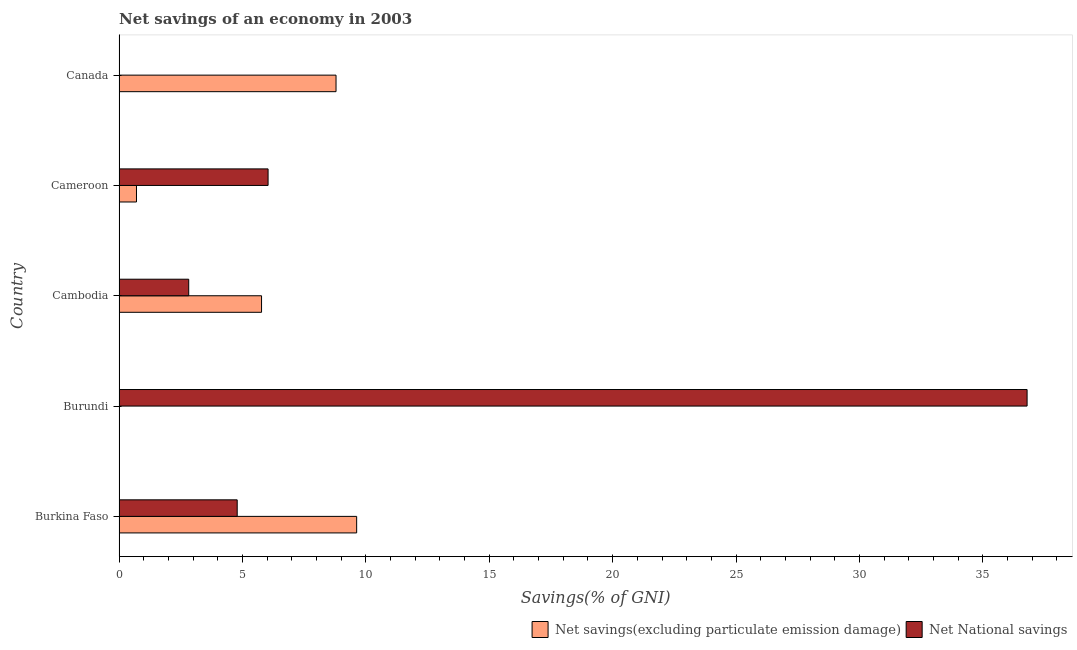Are the number of bars per tick equal to the number of legend labels?
Give a very brief answer. No. Are the number of bars on each tick of the Y-axis equal?
Keep it short and to the point. No. What is the label of the 2nd group of bars from the top?
Ensure brevity in your answer.  Cameroon. What is the net national savings in Burundi?
Make the answer very short. 36.79. Across all countries, what is the maximum net savings(excluding particulate emission damage)?
Your response must be concise. 9.63. In which country was the net savings(excluding particulate emission damage) maximum?
Your answer should be very brief. Burkina Faso. What is the total net savings(excluding particulate emission damage) in the graph?
Make the answer very short. 24.9. What is the difference between the net savings(excluding particulate emission damage) in Cambodia and that in Cameroon?
Provide a succinct answer. 5.07. What is the difference between the net national savings in Burundi and the net savings(excluding particulate emission damage) in Cambodia?
Ensure brevity in your answer.  31.02. What is the average net savings(excluding particulate emission damage) per country?
Ensure brevity in your answer.  4.98. What is the difference between the net savings(excluding particulate emission damage) and net national savings in Burkina Faso?
Provide a short and direct response. 4.84. In how many countries, is the net savings(excluding particulate emission damage) greater than 15 %?
Make the answer very short. 0. What is the ratio of the net national savings in Burundi to that in Cameroon?
Your answer should be compact. 6.09. Is the net savings(excluding particulate emission damage) in Burkina Faso less than that in Cameroon?
Ensure brevity in your answer.  No. Is the difference between the net national savings in Burkina Faso and Cameroon greater than the difference between the net savings(excluding particulate emission damage) in Burkina Faso and Cameroon?
Offer a terse response. No. What is the difference between the highest and the second highest net savings(excluding particulate emission damage)?
Your answer should be compact. 0.83. What is the difference between the highest and the lowest net national savings?
Provide a succinct answer. 36.79. Is the sum of the net national savings in Burkina Faso and Cameroon greater than the maximum net savings(excluding particulate emission damage) across all countries?
Ensure brevity in your answer.  Yes. How many countries are there in the graph?
Your answer should be compact. 5. What is the difference between two consecutive major ticks on the X-axis?
Give a very brief answer. 5. Does the graph contain any zero values?
Your answer should be very brief. Yes. What is the title of the graph?
Give a very brief answer. Net savings of an economy in 2003. What is the label or title of the X-axis?
Provide a short and direct response. Savings(% of GNI). What is the Savings(% of GNI) of Net savings(excluding particulate emission damage) in Burkina Faso?
Offer a terse response. 9.63. What is the Savings(% of GNI) in Net National savings in Burkina Faso?
Your answer should be very brief. 4.79. What is the Savings(% of GNI) in Net savings(excluding particulate emission damage) in Burundi?
Your response must be concise. 0. What is the Savings(% of GNI) of Net National savings in Burundi?
Make the answer very short. 36.79. What is the Savings(% of GNI) in Net savings(excluding particulate emission damage) in Cambodia?
Give a very brief answer. 5.77. What is the Savings(% of GNI) in Net National savings in Cambodia?
Provide a short and direct response. 2.82. What is the Savings(% of GNI) of Net savings(excluding particulate emission damage) in Cameroon?
Offer a terse response. 0.71. What is the Savings(% of GNI) of Net National savings in Cameroon?
Your response must be concise. 6.04. What is the Savings(% of GNI) in Net savings(excluding particulate emission damage) in Canada?
Offer a very short reply. 8.79. What is the Savings(% of GNI) in Net National savings in Canada?
Offer a terse response. 0. Across all countries, what is the maximum Savings(% of GNI) of Net savings(excluding particulate emission damage)?
Offer a very short reply. 9.63. Across all countries, what is the maximum Savings(% of GNI) of Net National savings?
Give a very brief answer. 36.79. Across all countries, what is the minimum Savings(% of GNI) in Net National savings?
Your answer should be very brief. 0. What is the total Savings(% of GNI) of Net savings(excluding particulate emission damage) in the graph?
Provide a succinct answer. 24.9. What is the total Savings(% of GNI) in Net National savings in the graph?
Your answer should be compact. 50.44. What is the difference between the Savings(% of GNI) in Net National savings in Burkina Faso and that in Burundi?
Provide a succinct answer. -32. What is the difference between the Savings(% of GNI) of Net savings(excluding particulate emission damage) in Burkina Faso and that in Cambodia?
Ensure brevity in your answer.  3.85. What is the difference between the Savings(% of GNI) in Net National savings in Burkina Faso and that in Cambodia?
Give a very brief answer. 1.96. What is the difference between the Savings(% of GNI) of Net savings(excluding particulate emission damage) in Burkina Faso and that in Cameroon?
Offer a terse response. 8.92. What is the difference between the Savings(% of GNI) in Net National savings in Burkina Faso and that in Cameroon?
Your response must be concise. -1.25. What is the difference between the Savings(% of GNI) in Net savings(excluding particulate emission damage) in Burkina Faso and that in Canada?
Your response must be concise. 0.84. What is the difference between the Savings(% of GNI) of Net National savings in Burundi and that in Cambodia?
Your answer should be very brief. 33.97. What is the difference between the Savings(% of GNI) of Net National savings in Burundi and that in Cameroon?
Offer a terse response. 30.75. What is the difference between the Savings(% of GNI) in Net savings(excluding particulate emission damage) in Cambodia and that in Cameroon?
Keep it short and to the point. 5.07. What is the difference between the Savings(% of GNI) in Net National savings in Cambodia and that in Cameroon?
Your answer should be compact. -3.22. What is the difference between the Savings(% of GNI) of Net savings(excluding particulate emission damage) in Cambodia and that in Canada?
Your answer should be compact. -3.02. What is the difference between the Savings(% of GNI) in Net savings(excluding particulate emission damage) in Cameroon and that in Canada?
Offer a very short reply. -8.09. What is the difference between the Savings(% of GNI) of Net savings(excluding particulate emission damage) in Burkina Faso and the Savings(% of GNI) of Net National savings in Burundi?
Provide a short and direct response. -27.16. What is the difference between the Savings(% of GNI) of Net savings(excluding particulate emission damage) in Burkina Faso and the Savings(% of GNI) of Net National savings in Cambodia?
Your response must be concise. 6.8. What is the difference between the Savings(% of GNI) in Net savings(excluding particulate emission damage) in Burkina Faso and the Savings(% of GNI) in Net National savings in Cameroon?
Your answer should be compact. 3.59. What is the difference between the Savings(% of GNI) in Net savings(excluding particulate emission damage) in Cambodia and the Savings(% of GNI) in Net National savings in Cameroon?
Provide a short and direct response. -0.26. What is the average Savings(% of GNI) of Net savings(excluding particulate emission damage) per country?
Give a very brief answer. 4.98. What is the average Savings(% of GNI) of Net National savings per country?
Keep it short and to the point. 10.09. What is the difference between the Savings(% of GNI) in Net savings(excluding particulate emission damage) and Savings(% of GNI) in Net National savings in Burkina Faso?
Keep it short and to the point. 4.84. What is the difference between the Savings(% of GNI) in Net savings(excluding particulate emission damage) and Savings(% of GNI) in Net National savings in Cambodia?
Offer a very short reply. 2.95. What is the difference between the Savings(% of GNI) of Net savings(excluding particulate emission damage) and Savings(% of GNI) of Net National savings in Cameroon?
Offer a very short reply. -5.33. What is the ratio of the Savings(% of GNI) of Net National savings in Burkina Faso to that in Burundi?
Your answer should be compact. 0.13. What is the ratio of the Savings(% of GNI) of Net savings(excluding particulate emission damage) in Burkina Faso to that in Cambodia?
Your response must be concise. 1.67. What is the ratio of the Savings(% of GNI) of Net National savings in Burkina Faso to that in Cambodia?
Ensure brevity in your answer.  1.7. What is the ratio of the Savings(% of GNI) in Net savings(excluding particulate emission damage) in Burkina Faso to that in Cameroon?
Your answer should be very brief. 13.63. What is the ratio of the Savings(% of GNI) in Net National savings in Burkina Faso to that in Cameroon?
Offer a terse response. 0.79. What is the ratio of the Savings(% of GNI) of Net savings(excluding particulate emission damage) in Burkina Faso to that in Canada?
Provide a short and direct response. 1.09. What is the ratio of the Savings(% of GNI) in Net National savings in Burundi to that in Cambodia?
Provide a succinct answer. 13.03. What is the ratio of the Savings(% of GNI) in Net National savings in Burundi to that in Cameroon?
Your response must be concise. 6.09. What is the ratio of the Savings(% of GNI) of Net savings(excluding particulate emission damage) in Cambodia to that in Cameroon?
Offer a very short reply. 8.17. What is the ratio of the Savings(% of GNI) of Net National savings in Cambodia to that in Cameroon?
Offer a terse response. 0.47. What is the ratio of the Savings(% of GNI) of Net savings(excluding particulate emission damage) in Cambodia to that in Canada?
Offer a very short reply. 0.66. What is the ratio of the Savings(% of GNI) in Net savings(excluding particulate emission damage) in Cameroon to that in Canada?
Provide a short and direct response. 0.08. What is the difference between the highest and the second highest Savings(% of GNI) of Net savings(excluding particulate emission damage)?
Offer a terse response. 0.84. What is the difference between the highest and the second highest Savings(% of GNI) in Net National savings?
Make the answer very short. 30.75. What is the difference between the highest and the lowest Savings(% of GNI) of Net savings(excluding particulate emission damage)?
Provide a short and direct response. 9.63. What is the difference between the highest and the lowest Savings(% of GNI) in Net National savings?
Your answer should be compact. 36.79. 